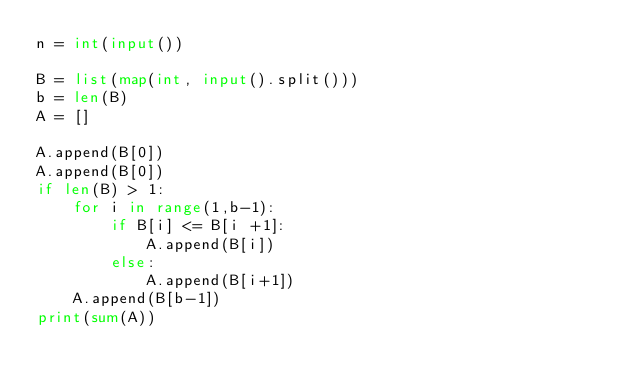Convert code to text. <code><loc_0><loc_0><loc_500><loc_500><_Python_>n = int(input())

B = list(map(int, input().split()))
b = len(B)
A = []

A.append(B[0])
A.append(B[0])
if len(B) > 1:
    for i in range(1,b-1):
        if B[i] <= B[i +1]:
            A.append(B[i])
        else:
            A.append(B[i+1])
    A.append(B[b-1])
print(sum(A))
        </code> 